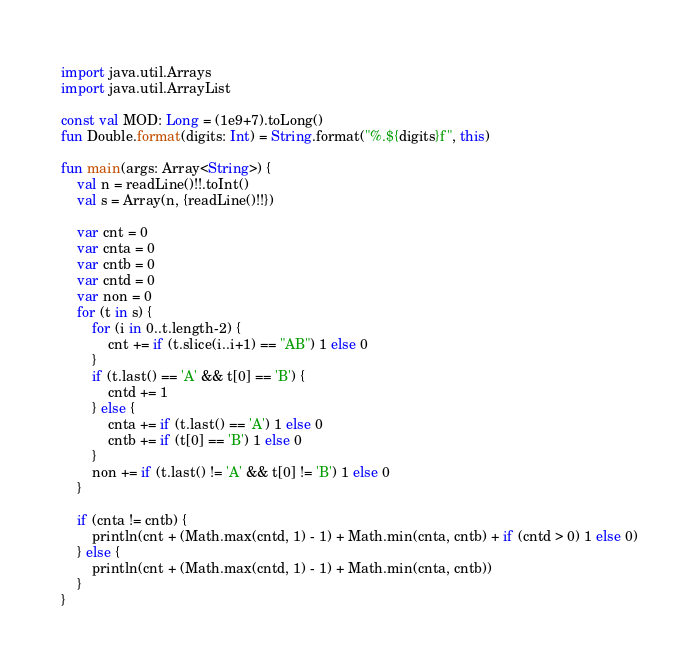<code> <loc_0><loc_0><loc_500><loc_500><_Kotlin_>import java.util.Arrays
import java.util.ArrayList

const val MOD: Long = (1e9+7).toLong()
fun Double.format(digits: Int) = String.format("%.${digits}f", this)

fun main(args: Array<String>) {
    val n = readLine()!!.toInt()
    val s = Array(n, {readLine()!!})

    var cnt = 0
    var cnta = 0
    var cntb = 0
    var cntd = 0
    var non = 0
    for (t in s) {
        for (i in 0..t.length-2) {
            cnt += if (t.slice(i..i+1) == "AB") 1 else 0
        }
        if (t.last() == 'A' && t[0] == 'B') {
            cntd += 1
        } else {
            cnta += if (t.last() == 'A') 1 else 0
            cntb += if (t[0] == 'B') 1 else 0
        }
        non += if (t.last() != 'A' && t[0] != 'B') 1 else 0
    }

    if (cnta != cntb) {
        println(cnt + (Math.max(cntd, 1) - 1) + Math.min(cnta, cntb) + if (cntd > 0) 1 else 0)
    } else {
        println(cnt + (Math.max(cntd, 1) - 1) + Math.min(cnta, cntb))
    }
}
</code> 